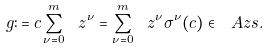<formula> <loc_0><loc_0><loc_500><loc_500>g \colon = c \sum _ { \nu = 0 } ^ { m } \ z ^ { \nu } = \sum _ { \nu = 0 } ^ { m } \ z ^ { \nu } \sigma ^ { \nu } ( c ) \in \ A z s .</formula> 